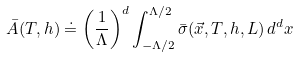<formula> <loc_0><loc_0><loc_500><loc_500>\bar { A } ( T , h ) \doteq \left ( \frac { 1 } { \Lambda } \right ) ^ { d } \int _ { - \Lambda / 2 } ^ { \Lambda / 2 } \bar { \sigma } ( \vec { x } , T , h , L ) \, d ^ { d } x</formula> 